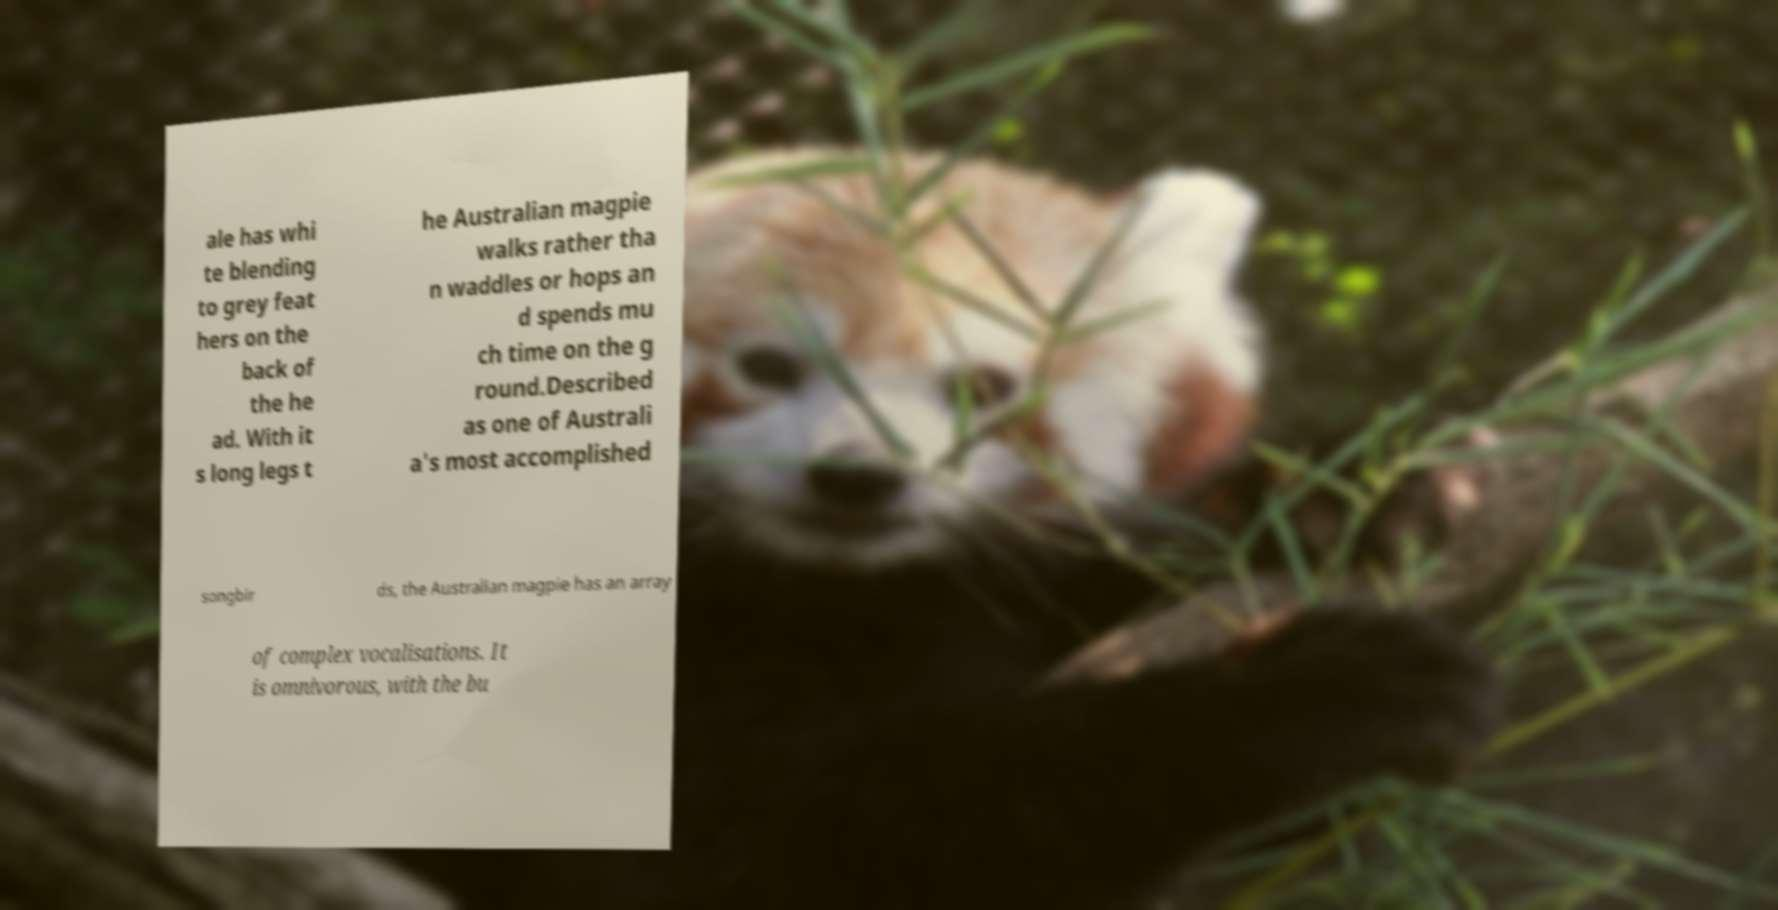Could you extract and type out the text from this image? ale has whi te blending to grey feat hers on the back of the he ad. With it s long legs t he Australian magpie walks rather tha n waddles or hops an d spends mu ch time on the g round.Described as one of Australi a's most accomplished songbir ds, the Australian magpie has an array of complex vocalisations. It is omnivorous, with the bu 